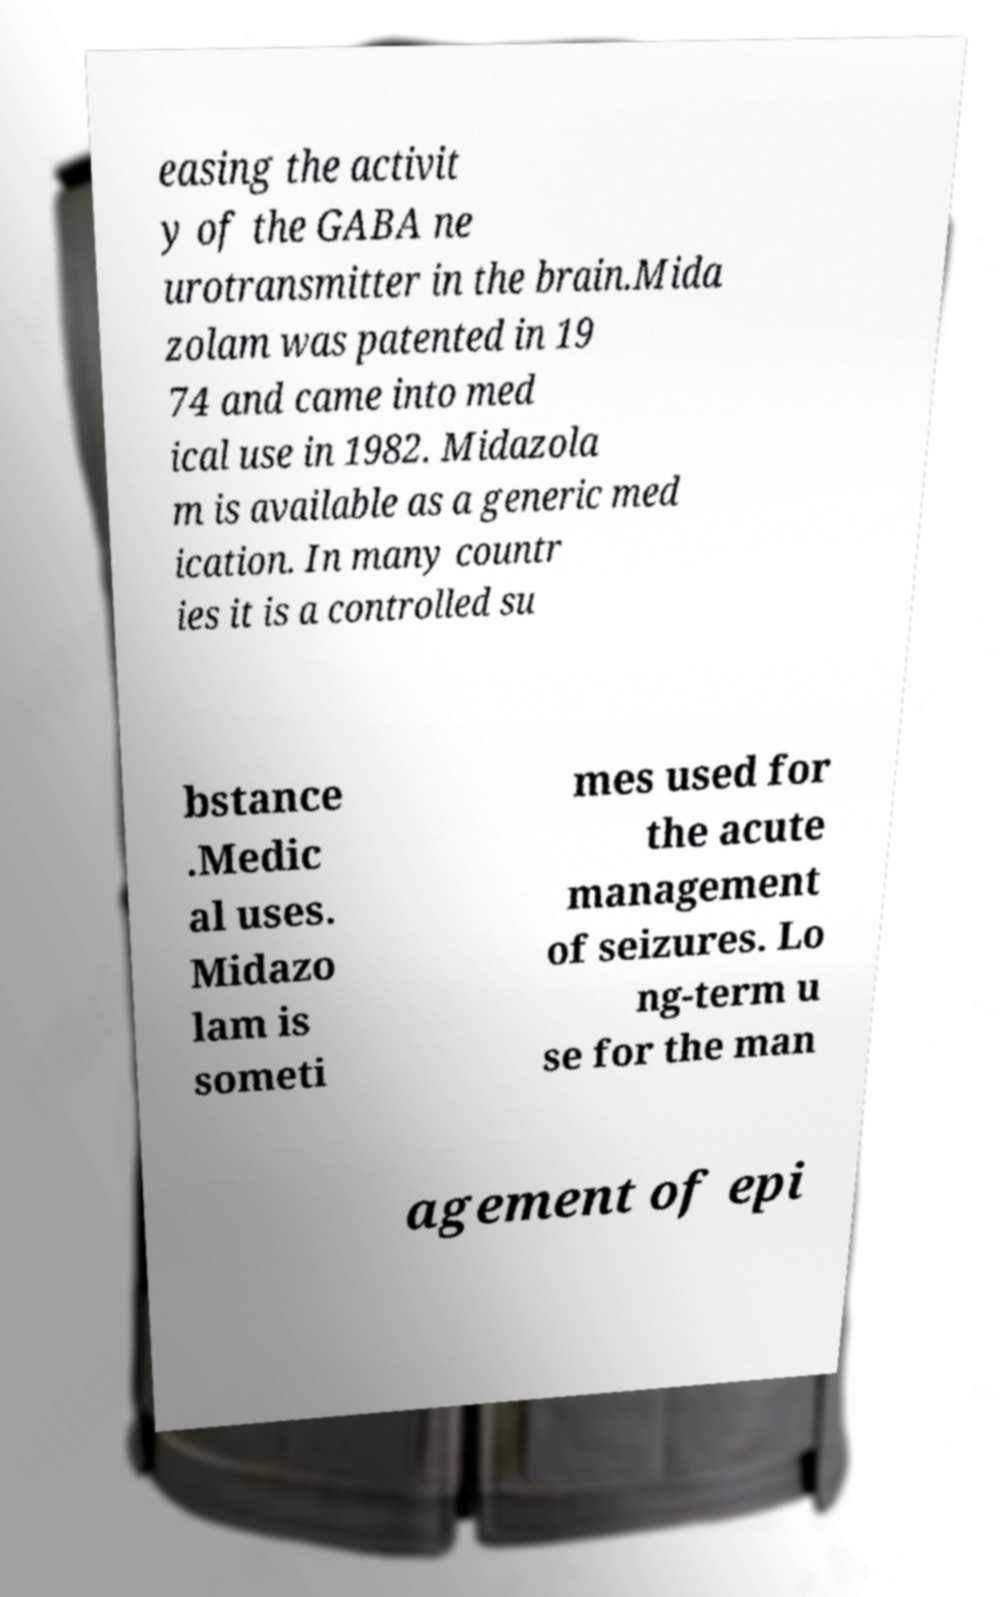There's text embedded in this image that I need extracted. Can you transcribe it verbatim? easing the activit y of the GABA ne urotransmitter in the brain.Mida zolam was patented in 19 74 and came into med ical use in 1982. Midazola m is available as a generic med ication. In many countr ies it is a controlled su bstance .Medic al uses. Midazo lam is someti mes used for the acute management of seizures. Lo ng-term u se for the man agement of epi 